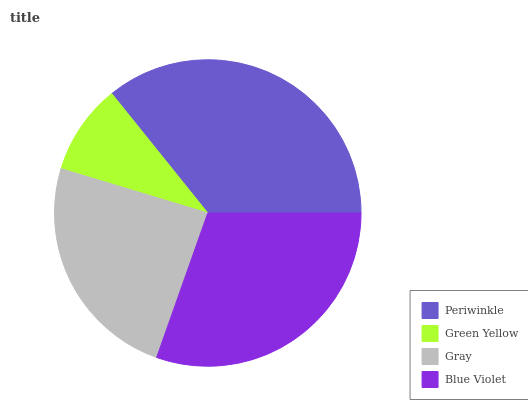Is Green Yellow the minimum?
Answer yes or no. Yes. Is Periwinkle the maximum?
Answer yes or no. Yes. Is Gray the minimum?
Answer yes or no. No. Is Gray the maximum?
Answer yes or no. No. Is Gray greater than Green Yellow?
Answer yes or no. Yes. Is Green Yellow less than Gray?
Answer yes or no. Yes. Is Green Yellow greater than Gray?
Answer yes or no. No. Is Gray less than Green Yellow?
Answer yes or no. No. Is Blue Violet the high median?
Answer yes or no. Yes. Is Gray the low median?
Answer yes or no. Yes. Is Green Yellow the high median?
Answer yes or no. No. Is Green Yellow the low median?
Answer yes or no. No. 